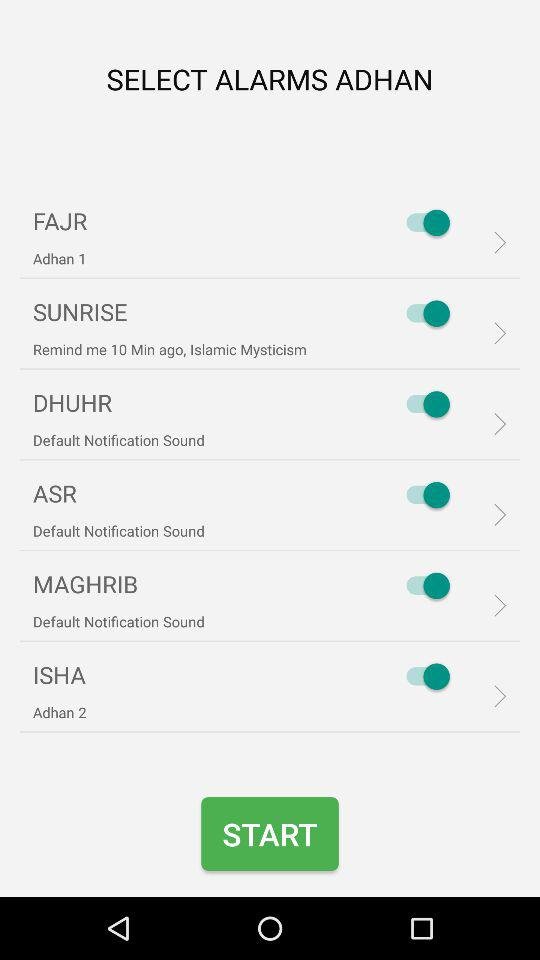What is the status of the "SUNRISE"? The status of the "SUNRISE" is "on". 